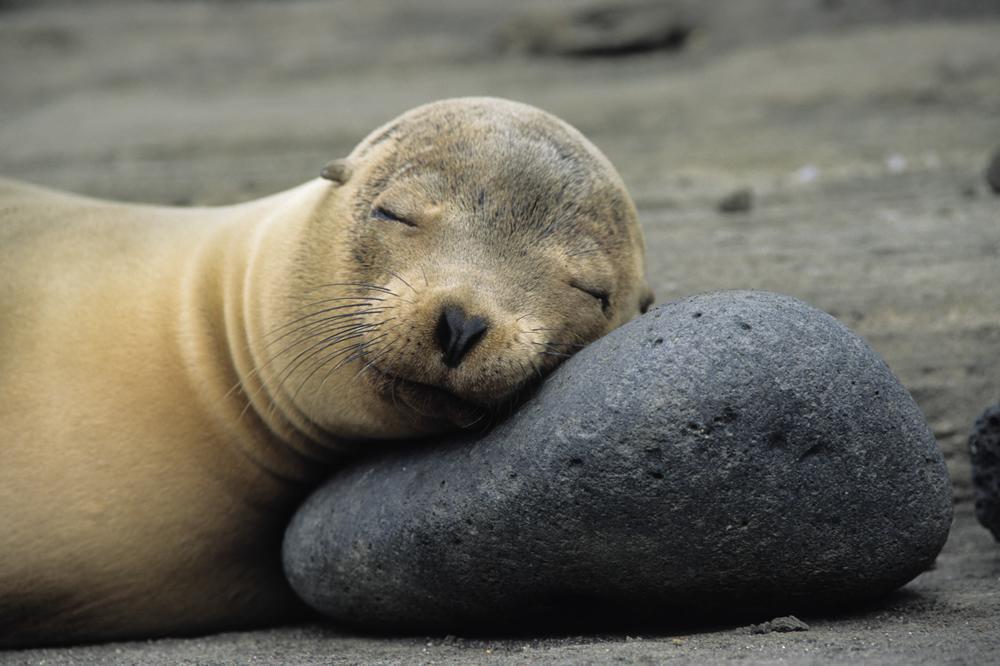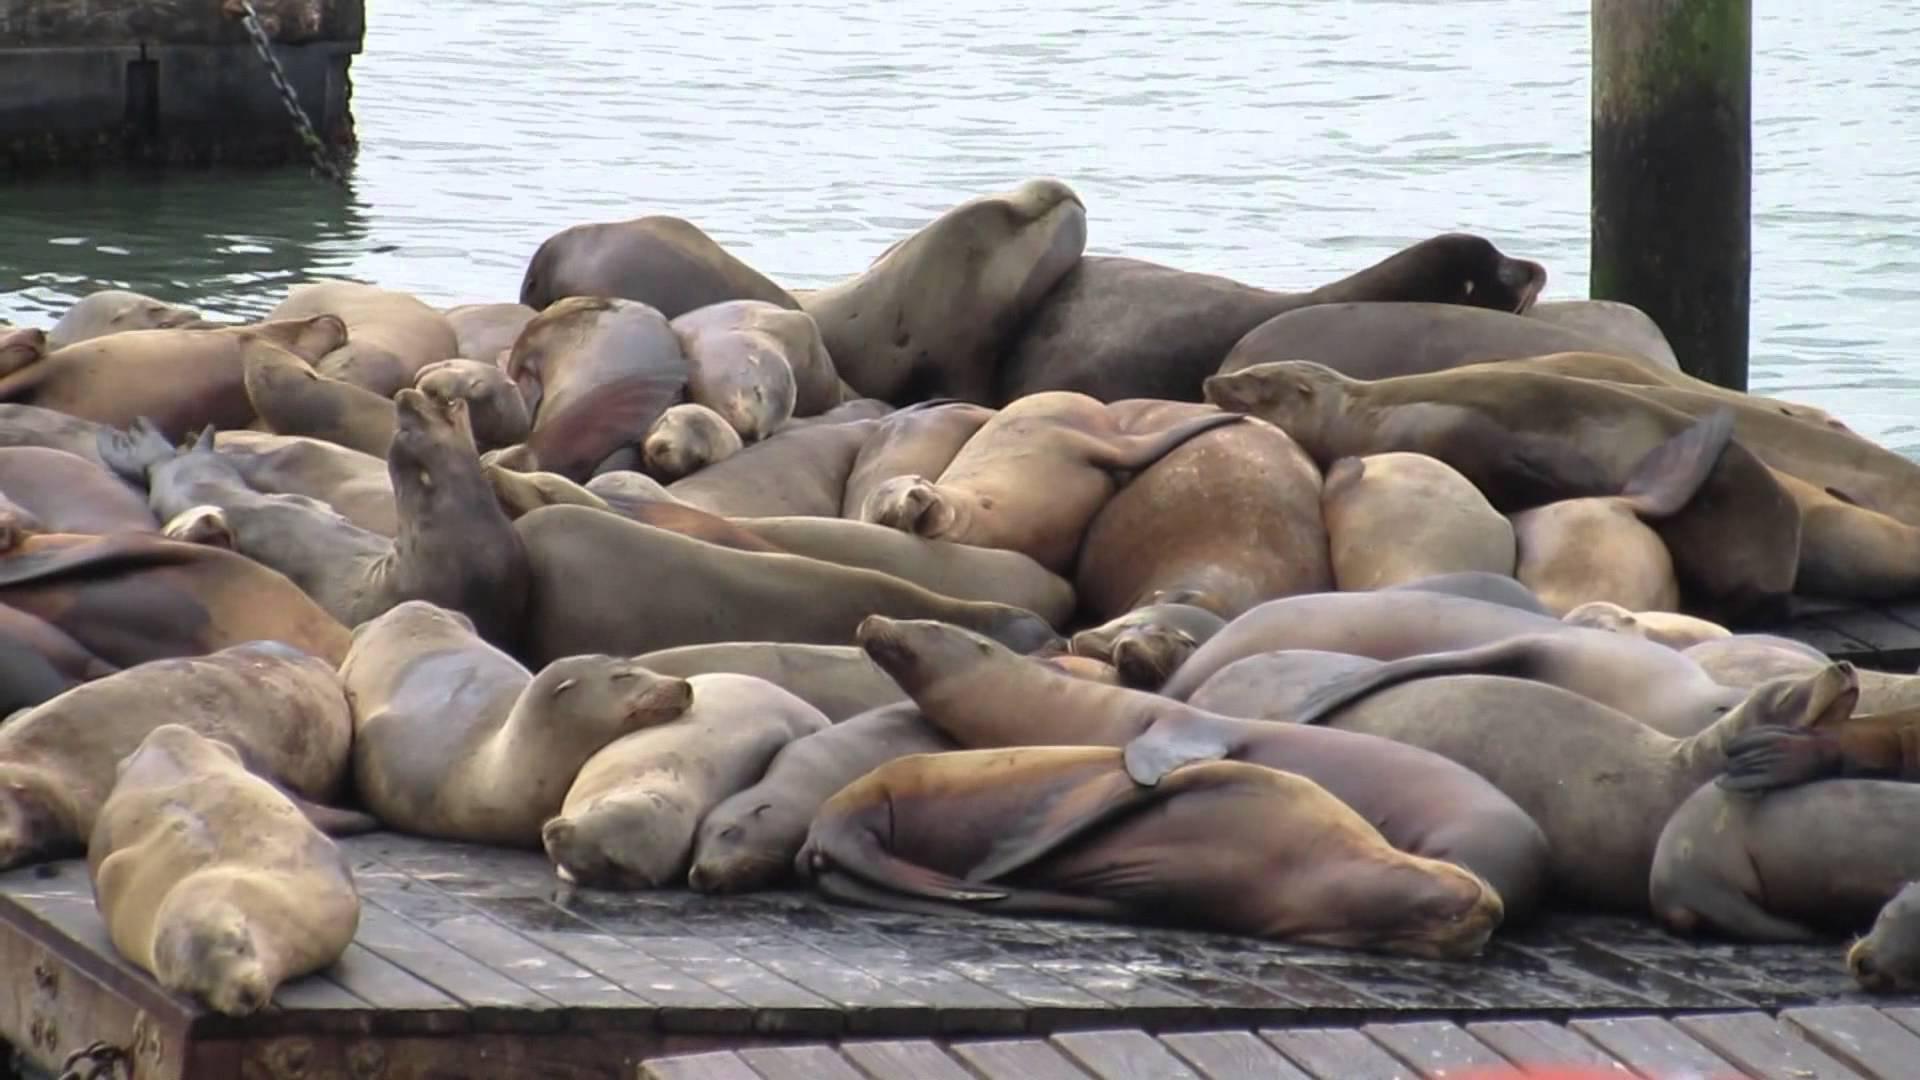The first image is the image on the left, the second image is the image on the right. Examine the images to the left and right. Is the description "In at least one image there are seals laying on a wooden dock" accurate? Answer yes or no. Yes. The first image is the image on the left, the second image is the image on the right. Given the left and right images, does the statement "One image has no more than three seals laying on rocks." hold true? Answer yes or no. Yes. 